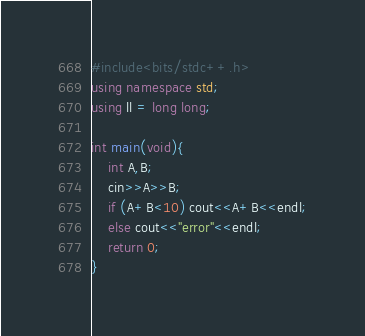<code> <loc_0><loc_0><loc_500><loc_500><_C++_>#include<bits/stdc++.h>
using namespace std;
using ll = long long;

int main(void){
    int A,B;
    cin>>A>>B;
    if (A+B<10) cout<<A+B<<endl;
    else cout<<"error"<<endl;
    return 0;
}</code> 